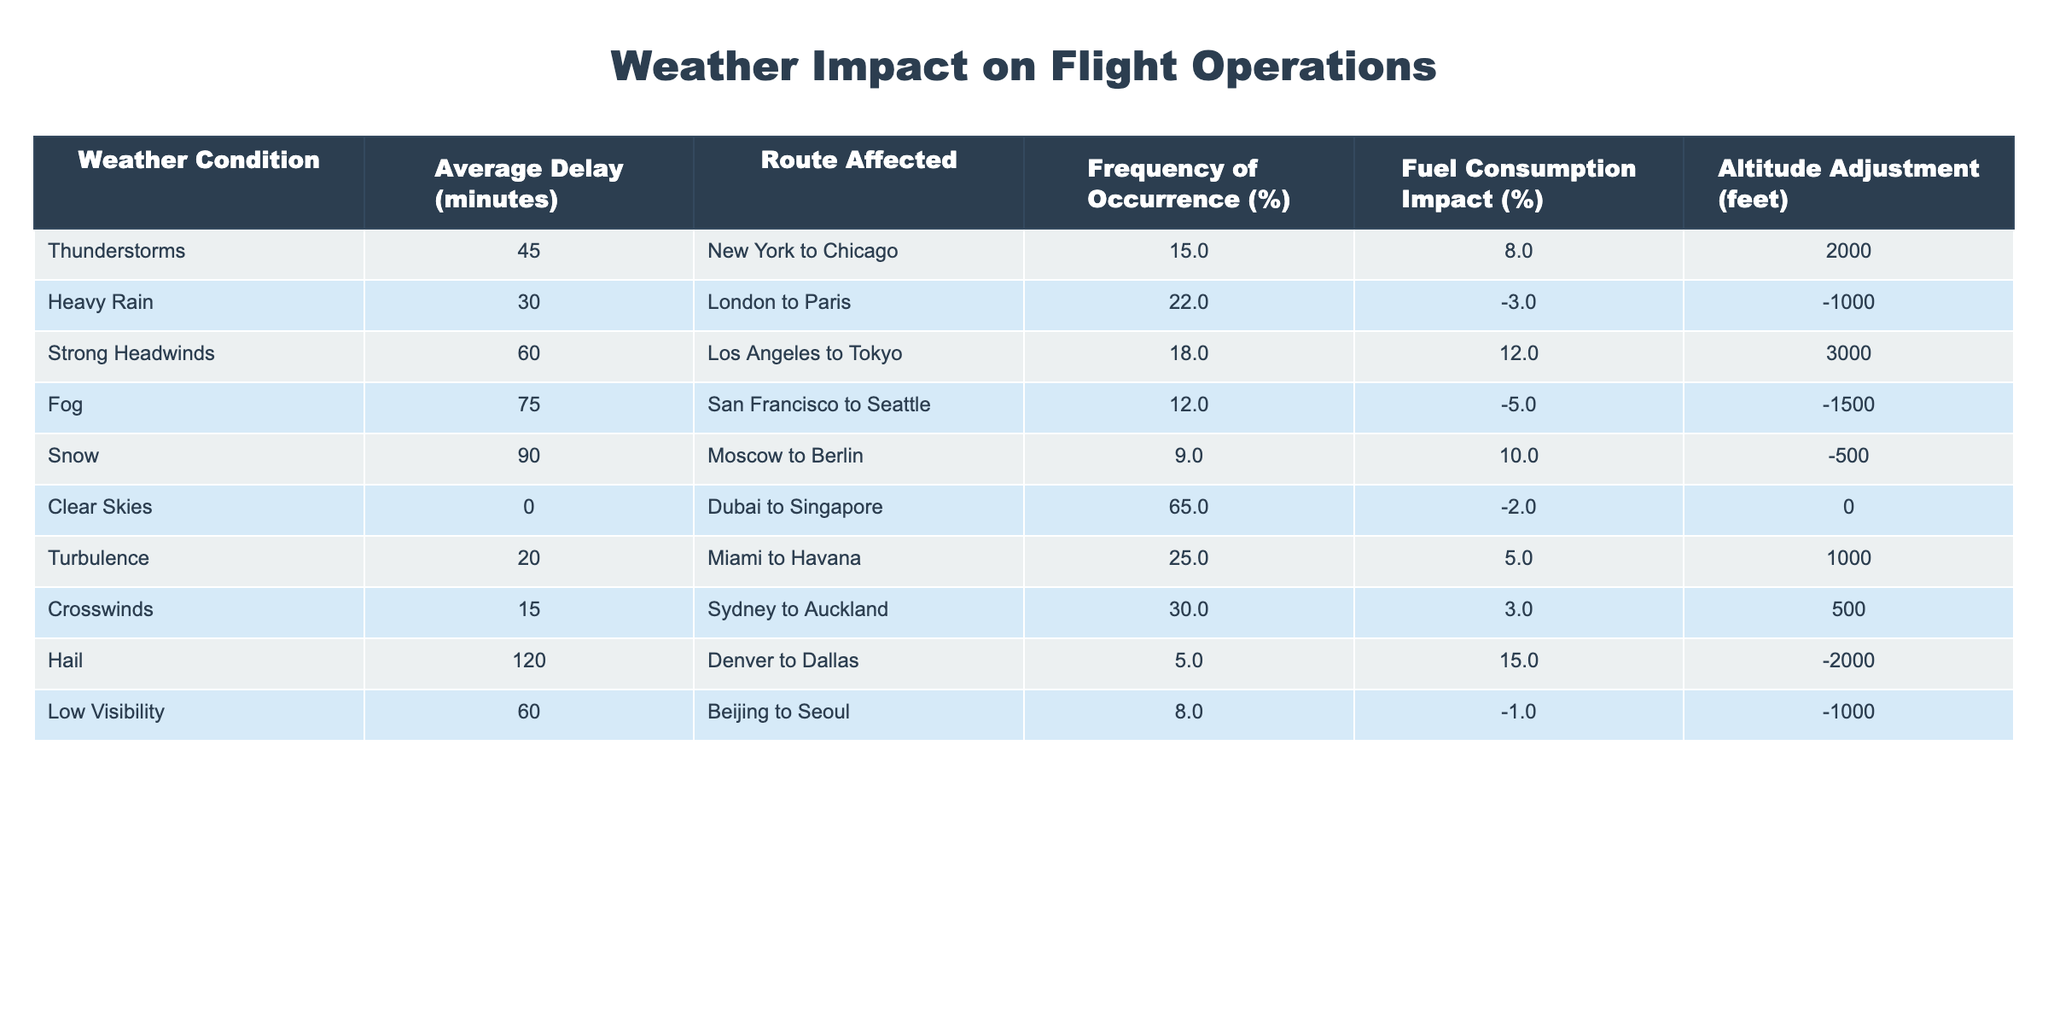What is the average delay caused by thunderstorms? According to the table, the average delay for thunderstorms is listed as 45 minutes.
Answer: 45 minutes Which route is affected by heavy rain? The table indicates that heavy rain affects the route from London to Paris.
Answer: London to Paris What is the fuel consumption impact of fog? The table shows that the fuel consumption impact of fog is -5%.
Answer: -5% How many weather conditions result in an average delay of 60 minutes or more? The table lists two conditions (strong headwinds and low visibility) with delays of 60 minutes or more, so we count those.
Answer: 2 What is the frequency of occurrence for crosswinds? The frequency of occurrence for crosswinds is 30%.
Answer: 30% Is the average delay caused by snow greater than that caused by heavy rain? Snow has an average delay of 90 minutes, while heavy rain has 30 minutes. Since 90 is greater than 30, the answer is yes.
Answer: Yes What is the average delay for routes affected by conditions with a fuel consumption impact greater than zero? The conditions with a positive fuel consumption impact are thunderstorms (+8%), strong headwinds (+12%), turbulence (+5%), and hail (+15%). Their average delays are 45, 60, 20, and 120 minutes respectively. Summing these gives 45 + 60 + 20 + 120 = 245 minutes and there are 4 conditions, so the average is 245 / 4 = 61.25 minutes.
Answer: 61.25 minutes Which route has the highest average delay and what is that delay? From examining the table, the route Denver to Dallas has the highest delay of 120 minutes due to hail.
Answer: Denver to Dallas, 120 minutes If clear skies exist 65% of the time, what percentage of the remaining time has severe weather conditions like thunderstorms and snow? The remaining percentage is 100% - 65% = 35%. Thunderstorms occur 15% and snow occurs 9%, giving a total of 15% + 9% = 24%.
Answer: 24% How does strong headwinds impact altitude adjustment compared to turbulence? Strong headwinds require an altitude adjustment of +3000 feet, while turbulence requires +1000 feet. The difference is 3000 - 1000 = 2000 feet.
Answer: 2000 feet difference 